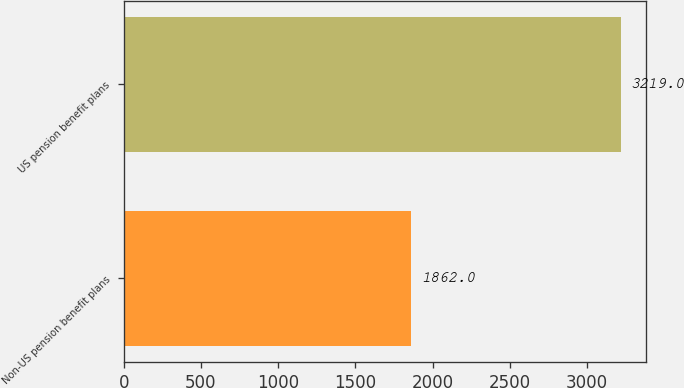Convert chart to OTSL. <chart><loc_0><loc_0><loc_500><loc_500><bar_chart><fcel>Non-US pension benefit plans<fcel>US pension benefit plans<nl><fcel>1862<fcel>3219<nl></chart> 